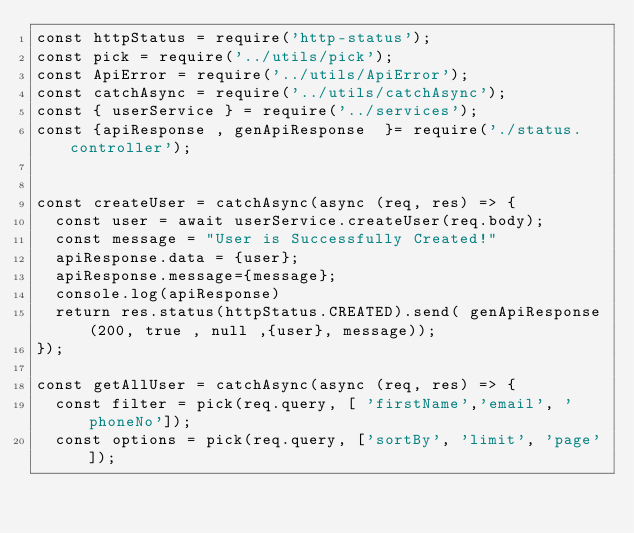<code> <loc_0><loc_0><loc_500><loc_500><_JavaScript_>const httpStatus = require('http-status');
const pick = require('../utils/pick');
const ApiError = require('../utils/ApiError');
const catchAsync = require('../utils/catchAsync');
const { userService } = require('../services');
const {apiResponse , genApiResponse  }= require('./status.controller');


const createUser = catchAsync(async (req, res) => {
  const user = await userService.createUser(req.body);
  const message = "User is Successfully Created!"
  apiResponse.data = {user};
  apiResponse.message={message};
  console.log(apiResponse)
  return res.status(httpStatus.CREATED).send( genApiResponse(200, true , null ,{user}, message));
});

const getAllUser = catchAsync(async (req, res) => {
  const filter = pick(req.query, [ 'firstName','email', 'phoneNo']);
  const options = pick(req.query, ['sortBy', 'limit', 'page']);</code> 